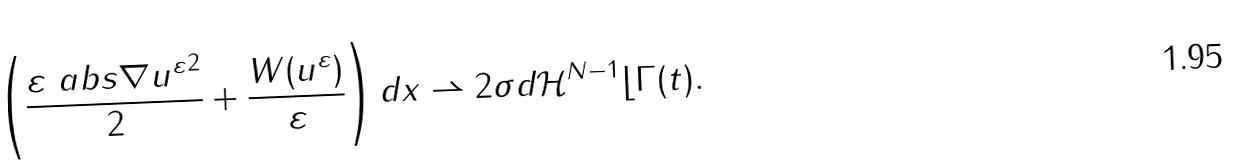<formula> <loc_0><loc_0><loc_500><loc_500>\left ( \frac { \varepsilon \ a b s { \nabla u ^ { \varepsilon } } ^ { 2 } } { 2 } + \frac { W ( u ^ { \varepsilon } ) } { \varepsilon } \right ) d x \rightharpoonup 2 \sigma d \mathcal { H } ^ { N - 1 } \lfloor \Gamma ( t ) .</formula> 